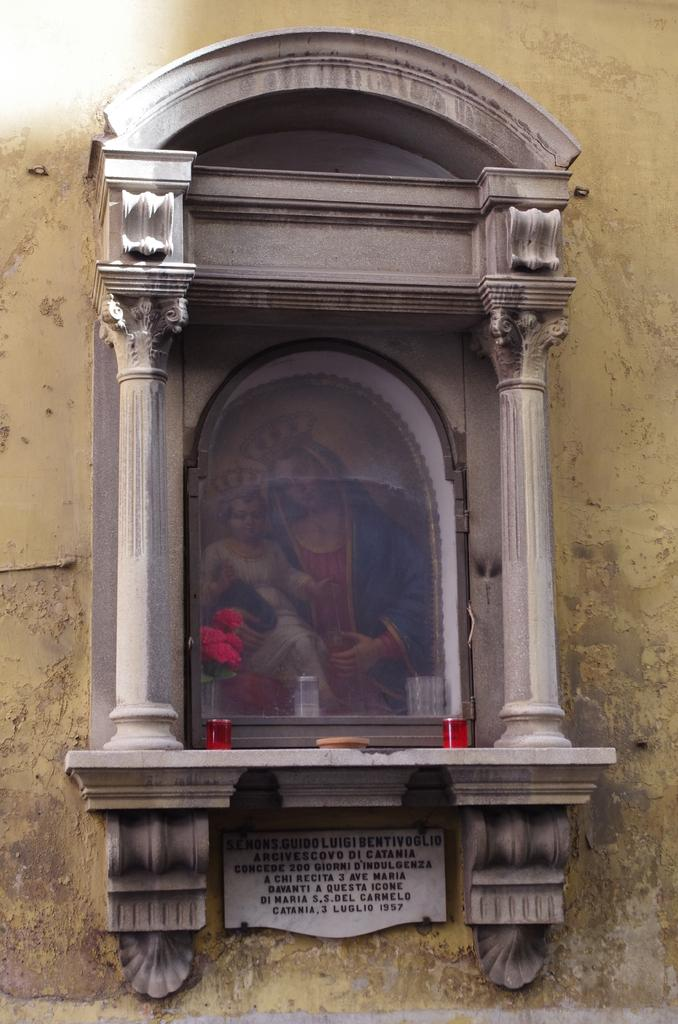What is the main object in the middle of the image? There is a photo frame in the middle of the image. What can be seen inside the photo frame? The photo frame contains an image of a woman holding a baby. What is attached to the wall beside the photo frame? There is a board attached to the wall beside the photo frame. How many apples are hanging from the photo frame in the image? There are no apples present in the image; the photo frame contains an image of a woman holding a baby. 